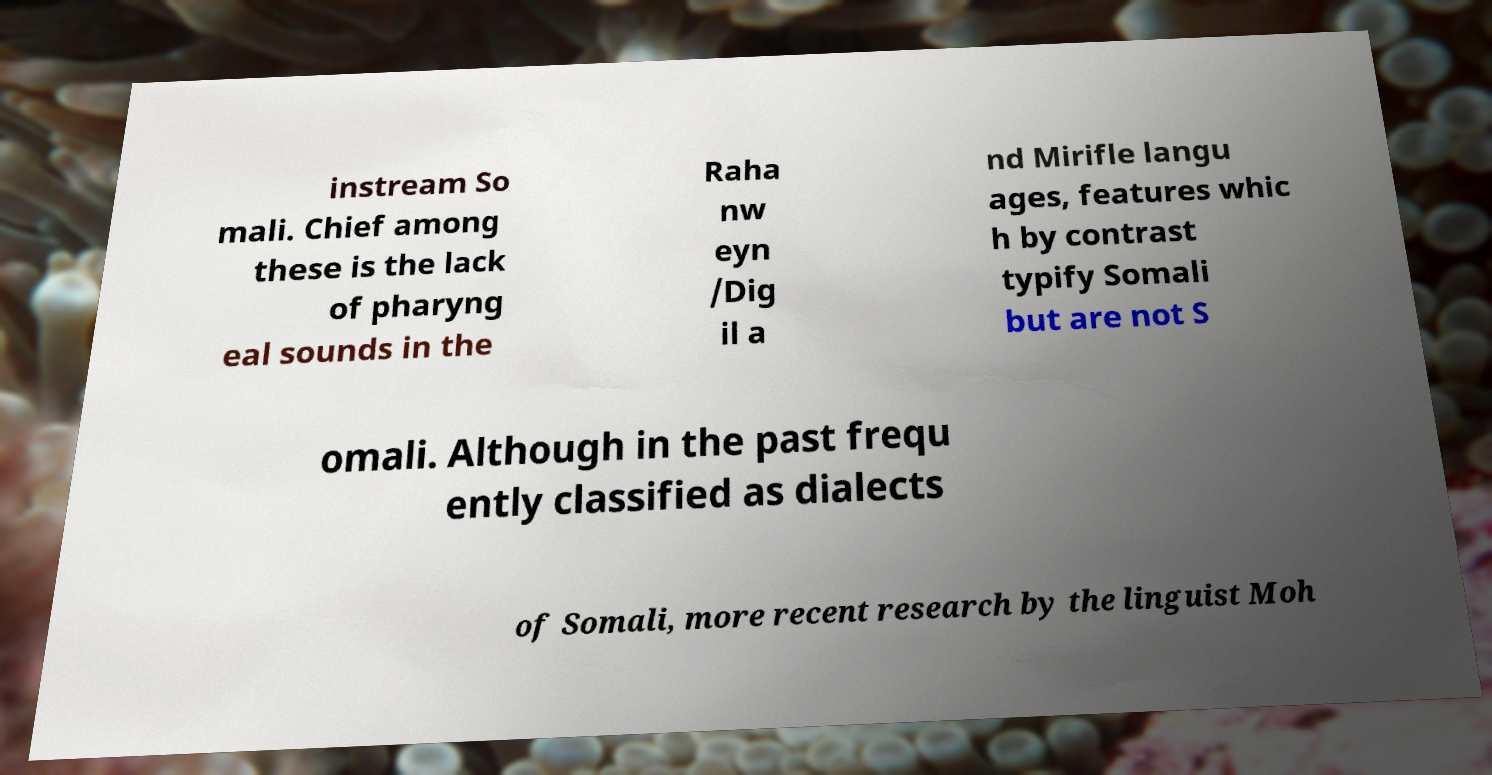Could you assist in decoding the text presented in this image and type it out clearly? instream So mali. Chief among these is the lack of pharyng eal sounds in the Raha nw eyn /Dig il a nd Mirifle langu ages, features whic h by contrast typify Somali but are not S omali. Although in the past frequ ently classified as dialects of Somali, more recent research by the linguist Moh 